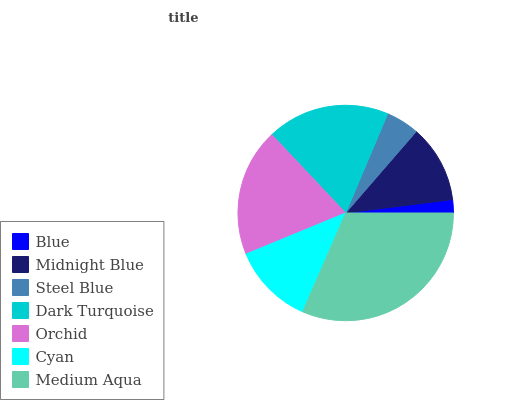Is Blue the minimum?
Answer yes or no. Yes. Is Medium Aqua the maximum?
Answer yes or no. Yes. Is Midnight Blue the minimum?
Answer yes or no. No. Is Midnight Blue the maximum?
Answer yes or no. No. Is Midnight Blue greater than Blue?
Answer yes or no. Yes. Is Blue less than Midnight Blue?
Answer yes or no. Yes. Is Blue greater than Midnight Blue?
Answer yes or no. No. Is Midnight Blue less than Blue?
Answer yes or no. No. Is Cyan the high median?
Answer yes or no. Yes. Is Cyan the low median?
Answer yes or no. Yes. Is Dark Turquoise the high median?
Answer yes or no. No. Is Dark Turquoise the low median?
Answer yes or no. No. 